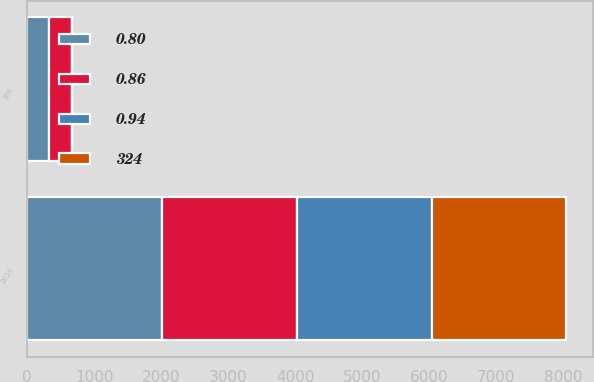Convert chart. <chart><loc_0><loc_0><loc_500><loc_500><stacked_bar_chart><ecel><fcel>2014<fcel>386<nl><fcel>0.94<fcel>2014<fcel>0.94<nl><fcel>0.86<fcel>2013<fcel>348<nl><fcel>324<fcel>2013<fcel>0.86<nl><fcel>0.8<fcel>2012<fcel>324<nl></chart> 